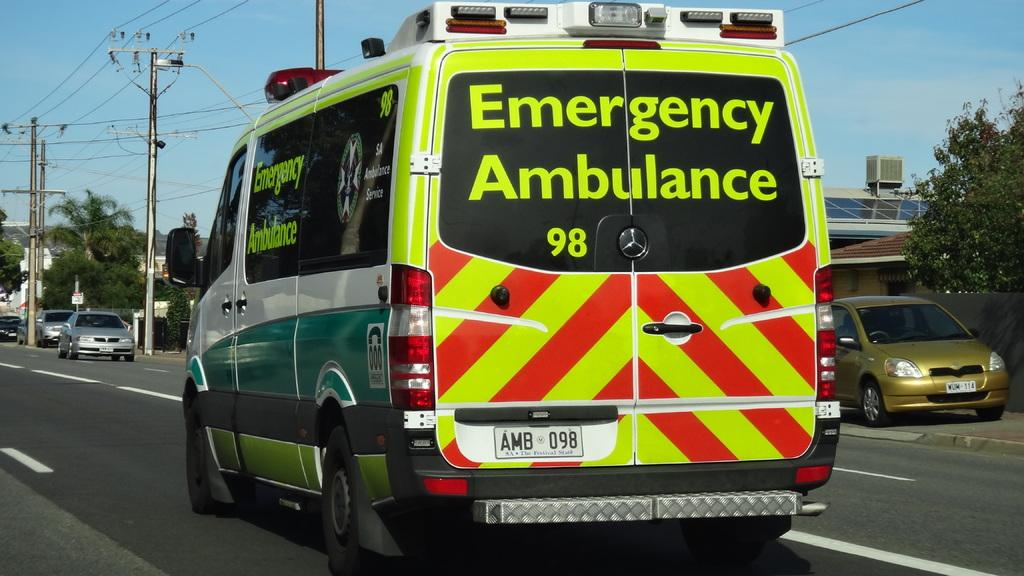Provide a one-sentence caption for the provided image. The vehicle shown travelling down the road is an Emergency Ambulance. 